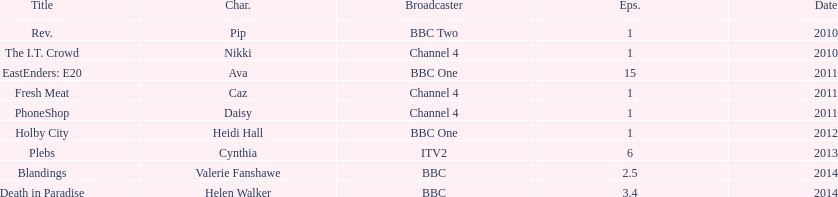How many television credits does this actress have? 9. 